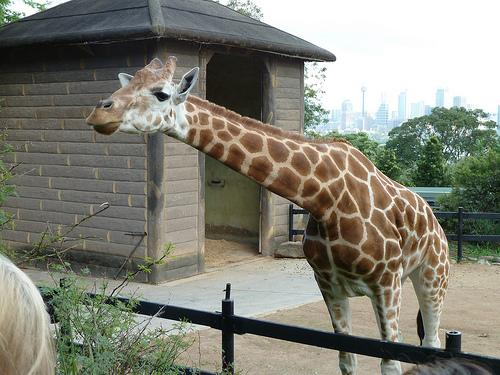Discuss the interaction between the giraffe and its environment. The giraffe appears curious as it looks around its surroundings, which includes a fenced area, a building, and green vegetation in the background of the zoo setting. What is the weather like in the image? The image depicts a bright day, indicated by the lack of shadows or poor lighting. Describe the fence that is surrounding the giraffe. The fence is made of metal, painted black, and acts to keep the giraffe in its area. What is the primary animal in the image? The primary animal in the image is a giraffe with a long neck and a curious expression. Can you identify the hair color of the person at the zoo? The person at the zoo has blonde hair. Give a brief description of the surroundings where the giraffe is. The giraffe is in a zoo, surrounded by a metal fence, a building for the giraffe to go in, and green trees in the background. How many different types of vegetation can you find within the image? There are green bushes, green trees, and a green plant in the image. List the colors of the giraffe. The giraffe is mainly white and brown, with brown spots and white lines. What is a notable facial feature of the giraffe? The giraffe has horns on its head and distinctive lips and nostrils. What's the purpose of the metal fence in the image? The metal fence is there to keep the giraffe inside its designated area within the zoo. Describe the weather conditions in the image. bright day Rate the image quality on a scale from 1 to 10. 8 Is the hidden animal on the right side of the image? The instruction is misleading because it's mentioned that there's a hidden animal on the left, not on the right. Does the giraffe appear to be in a natural habitat or a human-made enclosure? human-made enclosure Is the giraffe standing on grass or dirt? dirt What does the phrase "long necked curious giraffe" refer to in the image? giraffe Is the person at the zoo easily visible or well-hidden in the image? hidden Is the giraffe's neck short in length? This instruction contradicts the actual information provided, which mentions the long neck of the giraffe. Describe the colors of the fence keeping the giraffe in. black List three attributes of the giraffe in the image. white and brown, long neck, horns Is the giraffe's head free from any horns? This instruction is misleading because it's clearly stated that the giraffe has horns on its head. How would you describe the interaction between the giraffe and the environment? The giraffe is looking curious and exploring its surroundings, while being confined by a metal fence. List all of the elements found on the ground, like objects or items. dirt, fence, ground, floor Is the giraffe standing near a blue fence? The instruction is misleading because the metal fence mentioned in the image is painted black, not blue. What emotions does the giraffe appear to be displaying? curious Find the word or words to describe the trees in the background. green Are there any yellow trees in the background? The instruction is misleading because it's mentioned that the trees in the background are green, not yellow. What is a unique feature of a giraffe that is clearly visible in the image? long neck Mention any anomalies found in the image. None What is the purpose of the metal fence in the image? to keep the giraffe in Can you spot a person with red hair at the zoo? The instruction is misleading because there is only mention of a person with blonde hair, not red hair. List two colors found on the giraffe's body. white, brown Name the attributes of the giraffe's head, such as its shapes or patterns. horns, lips, nostrils 